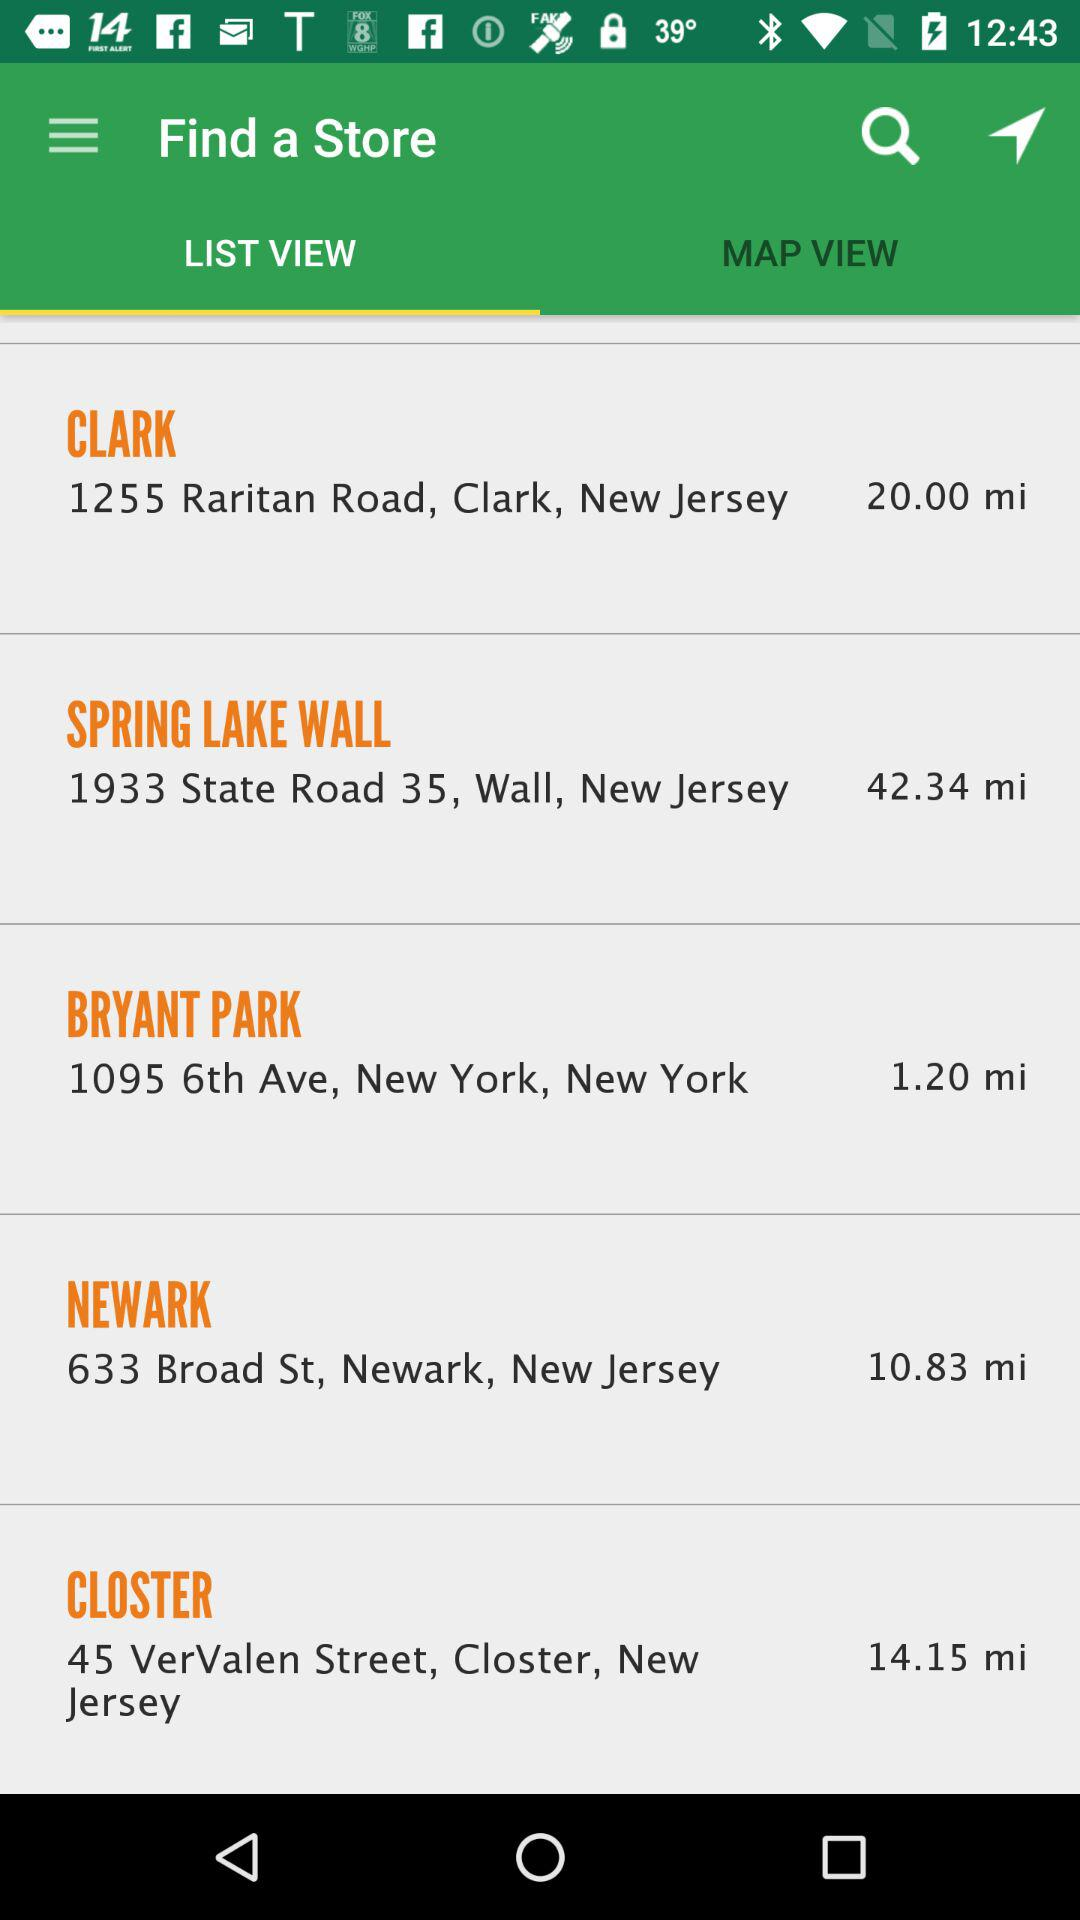How far away is Clark? Clark is 20 miles away. 